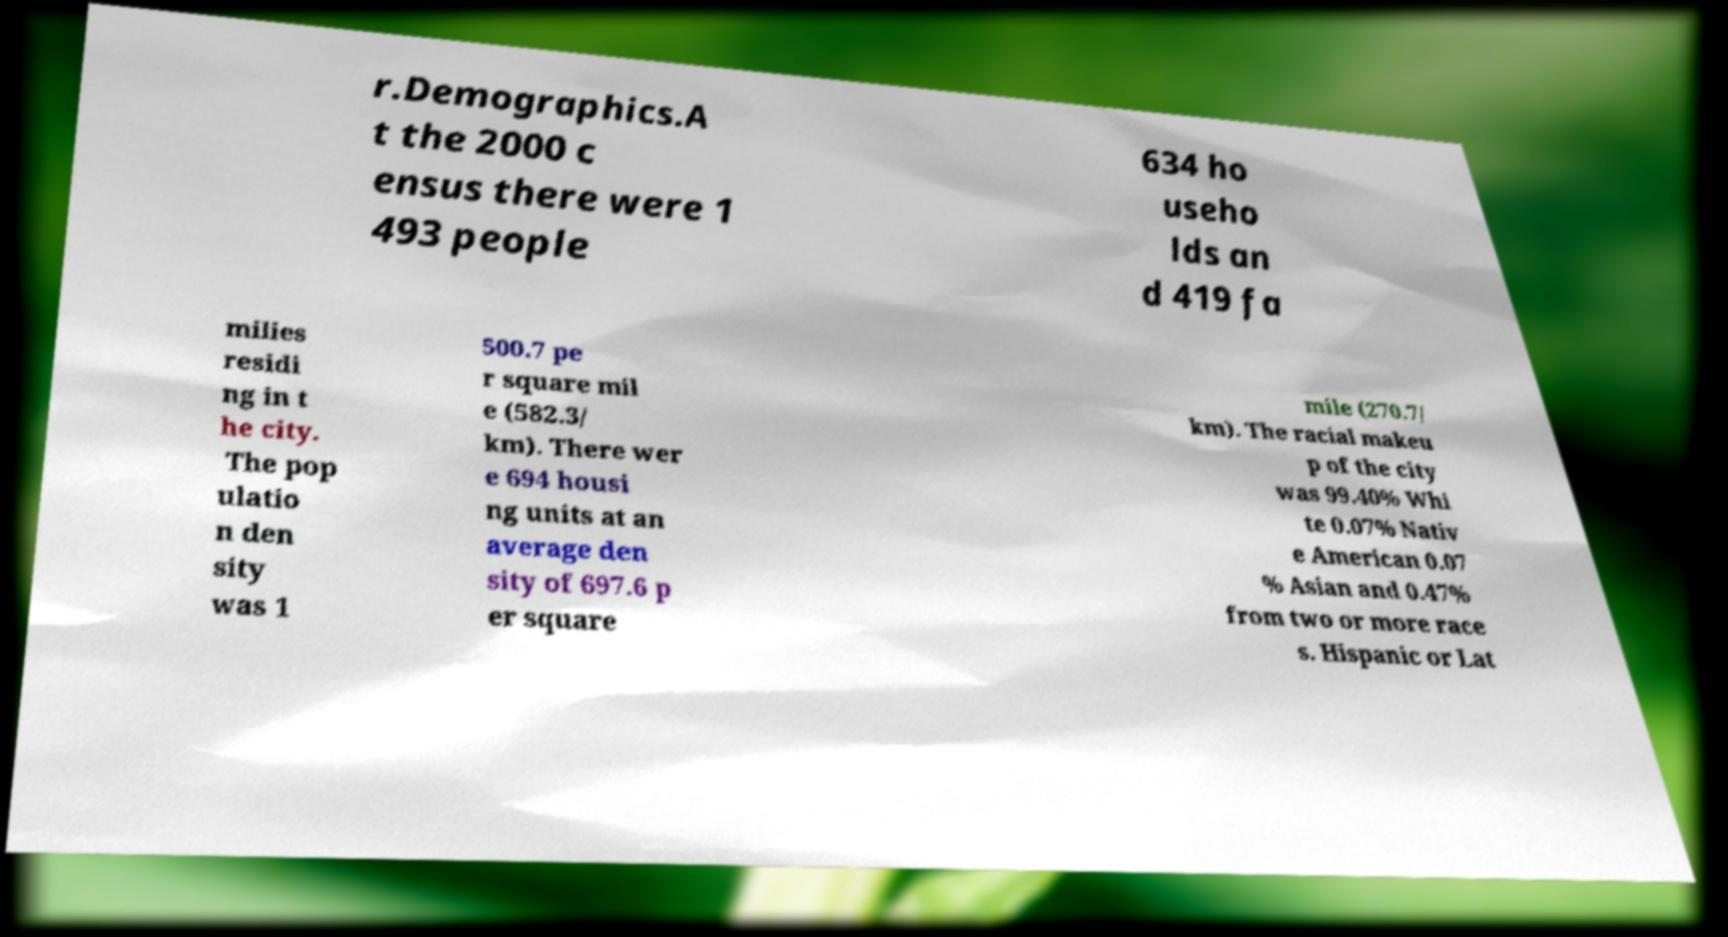Please identify and transcribe the text found in this image. r.Demographics.A t the 2000 c ensus there were 1 493 people 634 ho useho lds an d 419 fa milies residi ng in t he city. The pop ulatio n den sity was 1 500.7 pe r square mil e (582.3/ km). There wer e 694 housi ng units at an average den sity of 697.6 p er square mile (270.7/ km). The racial makeu p of the city was 99.40% Whi te 0.07% Nativ e American 0.07 % Asian and 0.47% from two or more race s. Hispanic or Lat 